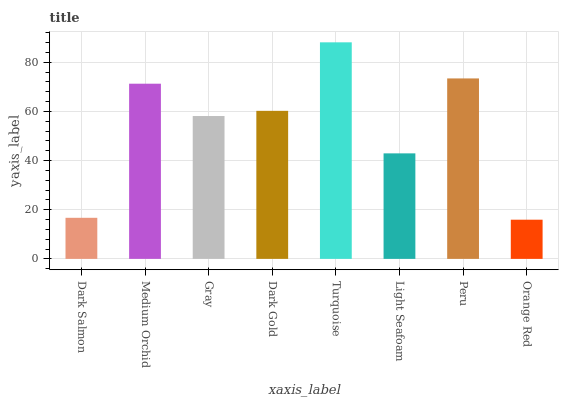Is Orange Red the minimum?
Answer yes or no. Yes. Is Turquoise the maximum?
Answer yes or no. Yes. Is Medium Orchid the minimum?
Answer yes or no. No. Is Medium Orchid the maximum?
Answer yes or no. No. Is Medium Orchid greater than Dark Salmon?
Answer yes or no. Yes. Is Dark Salmon less than Medium Orchid?
Answer yes or no. Yes. Is Dark Salmon greater than Medium Orchid?
Answer yes or no. No. Is Medium Orchid less than Dark Salmon?
Answer yes or no. No. Is Dark Gold the high median?
Answer yes or no. Yes. Is Gray the low median?
Answer yes or no. Yes. Is Dark Salmon the high median?
Answer yes or no. No. Is Light Seafoam the low median?
Answer yes or no. No. 